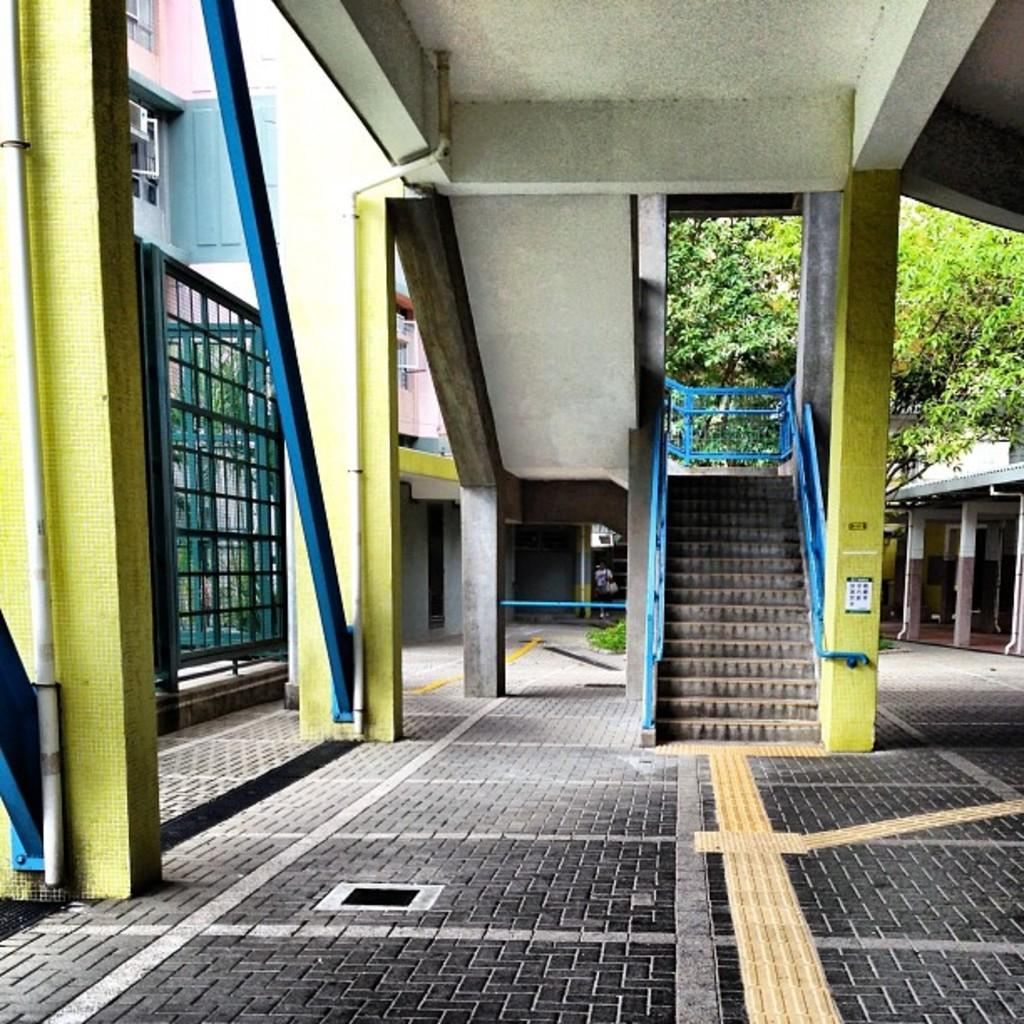What type of architectural feature can be seen in the image? There are steps in the image. What type of structure is present in the image? There is a building with windows in the image. What can be seen in the background of the image? There is a tree in the background of the image. What structural elements support the building in the image? There are pillars in the image. Is there any sign of human presence in the image? Yes, a person is visible in the distance. What type of sound can be heard coming from the system in the image? There is no system or sound present in the image; it features steps, a building, a tree, pillars, and a person in the distance. 